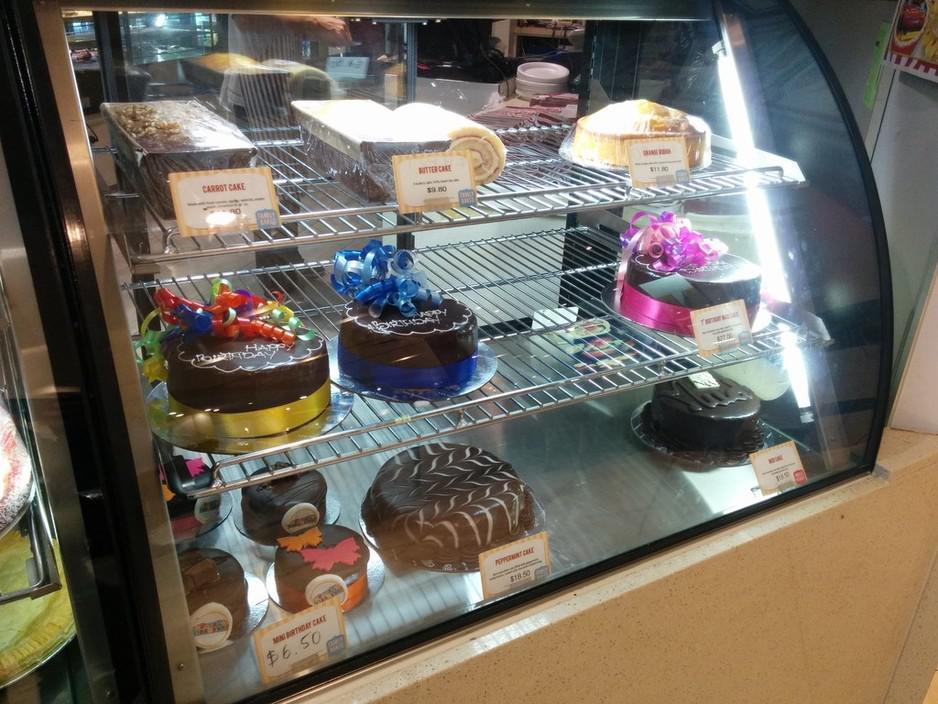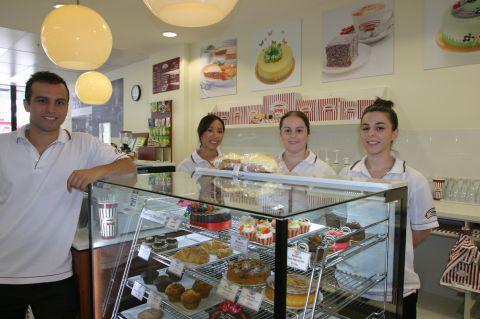The first image is the image on the left, the second image is the image on the right. Analyze the images presented: Is the assertion "A woman in white with her hair in a bun stands behind a counter in one image." valid? Answer yes or no. Yes. The first image is the image on the left, the second image is the image on the right. For the images shown, is this caption "There is a female wearing her hair in a high bun next to some pastries." true? Answer yes or no. Yes. 